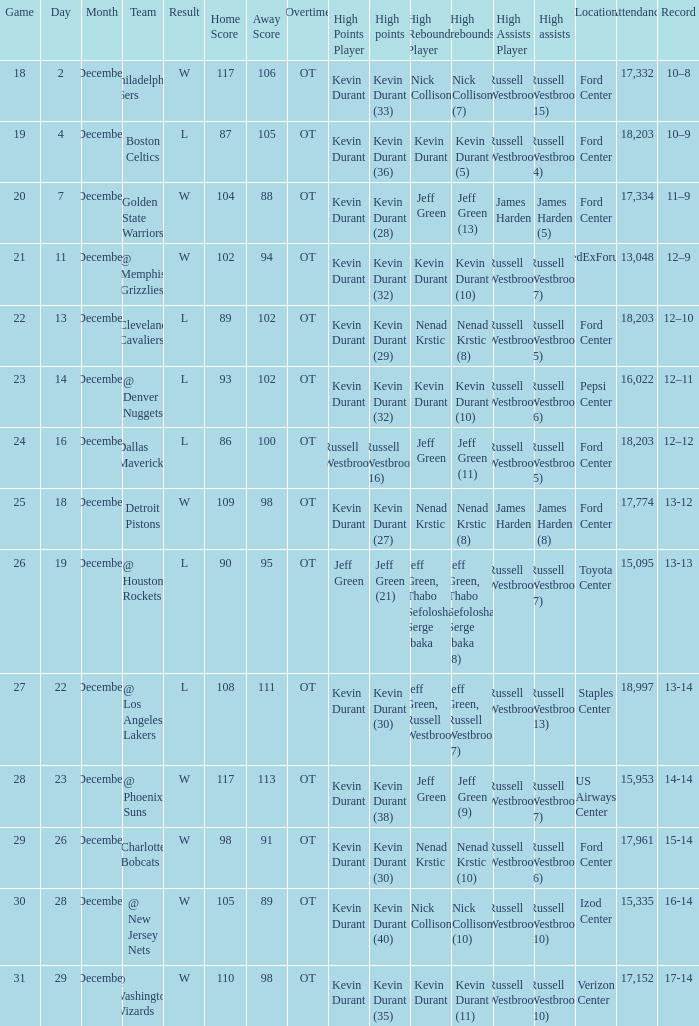Who has high points when toyota center 15,095 is location attendance? Jeff Green (21). 